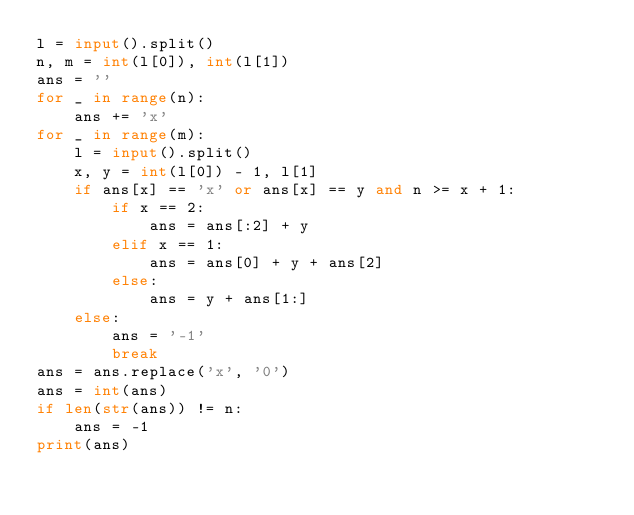Convert code to text. <code><loc_0><loc_0><loc_500><loc_500><_Python_>l = input().split()
n, m = int(l[0]), int(l[1])
ans = ''
for _ in range(n):
    ans += 'x'
for _ in range(m):
    l = input().split()
    x, y = int(l[0]) - 1, l[1]
    if ans[x] == 'x' or ans[x] == y and n >= x + 1:
        if x == 2:
            ans = ans[:2] + y
        elif x == 1:
            ans = ans[0] + y + ans[2]
        else:
            ans = y + ans[1:]
    else:
        ans = '-1'
        break
ans = ans.replace('x', '0')
ans = int(ans)
if len(str(ans)) != n:
    ans = -1
print(ans)</code> 